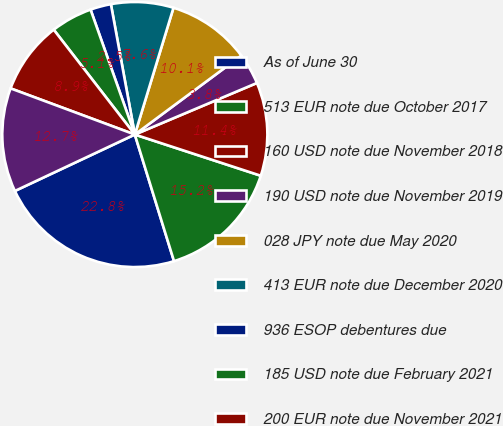<chart> <loc_0><loc_0><loc_500><loc_500><pie_chart><fcel>As of June 30<fcel>513 EUR note due October 2017<fcel>160 USD note due November 2018<fcel>190 USD note due November 2019<fcel>028 JPY note due May 2020<fcel>413 EUR note due December 2020<fcel>936 ESOP debentures due<fcel>185 USD note due February 2021<fcel>200 EUR note due November 2021<fcel>230 USD note due February 2022<nl><fcel>22.78%<fcel>15.19%<fcel>11.39%<fcel>3.8%<fcel>10.13%<fcel>7.6%<fcel>2.53%<fcel>5.06%<fcel>8.86%<fcel>12.66%<nl></chart> 